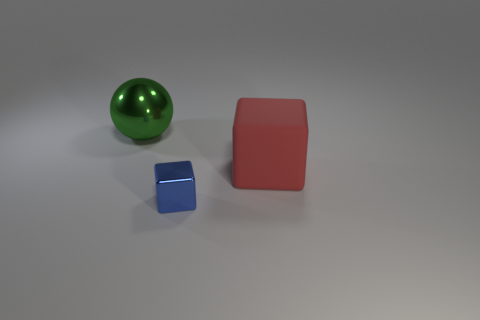What number of tiny metal cubes are right of the big object that is to the right of the metal cube?
Your answer should be very brief. 0. There is a red object that is the same size as the green metal thing; what is it made of?
Your answer should be compact. Rubber. How many other things are there of the same material as the green sphere?
Provide a succinct answer. 1. How many large metallic spheres are to the left of the large green metal object?
Your answer should be compact. 0. What number of blocks are either gray rubber things or metal objects?
Your response must be concise. 1. How big is the object that is left of the red thing and on the right side of the big metallic sphere?
Keep it short and to the point. Small. How many other things are the same color as the large metal ball?
Your response must be concise. 0. Do the big red cube and the big thing on the left side of the red rubber object have the same material?
Your answer should be very brief. No. What number of objects are either large things that are to the right of the green sphere or green metal cylinders?
Offer a terse response. 1. The thing that is both in front of the big metallic sphere and on the left side of the large red rubber block has what shape?
Give a very brief answer. Cube. 